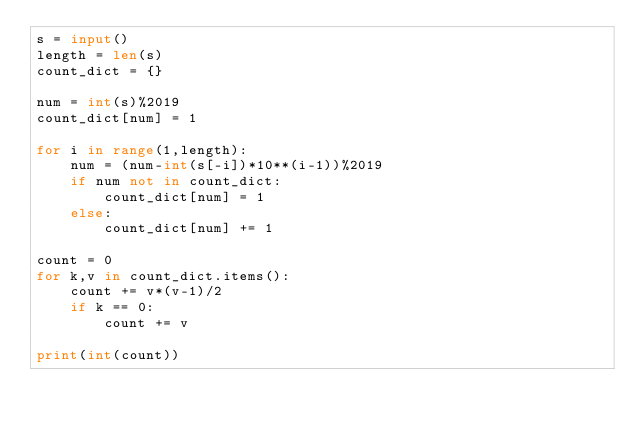<code> <loc_0><loc_0><loc_500><loc_500><_Python_>s = input()
length = len(s)
count_dict = {}

num = int(s)%2019
count_dict[num] = 1

for i in range(1,length):
    num = (num-int(s[-i])*10**(i-1))%2019
    if num not in count_dict:
        count_dict[num] = 1
    else:
        count_dict[num] += 1

count = 0
for k,v in count_dict.items():
    count += v*(v-1)/2
    if k == 0:
        count += v

print(int(count))</code> 